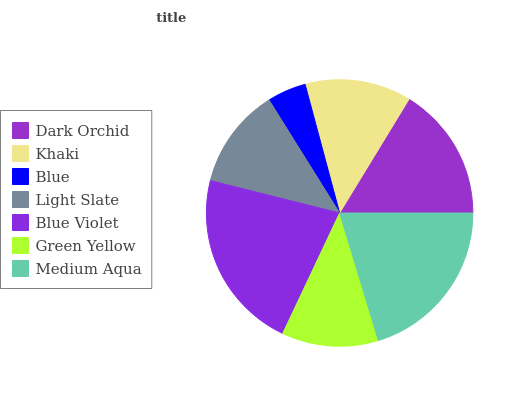Is Blue the minimum?
Answer yes or no. Yes. Is Blue Violet the maximum?
Answer yes or no. Yes. Is Khaki the minimum?
Answer yes or no. No. Is Khaki the maximum?
Answer yes or no. No. Is Dark Orchid greater than Khaki?
Answer yes or no. Yes. Is Khaki less than Dark Orchid?
Answer yes or no. Yes. Is Khaki greater than Dark Orchid?
Answer yes or no. No. Is Dark Orchid less than Khaki?
Answer yes or no. No. Is Khaki the high median?
Answer yes or no. Yes. Is Khaki the low median?
Answer yes or no. Yes. Is Medium Aqua the high median?
Answer yes or no. No. Is Dark Orchid the low median?
Answer yes or no. No. 